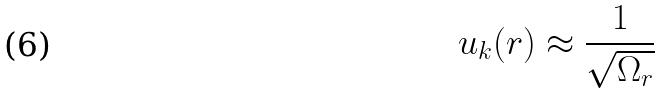<formula> <loc_0><loc_0><loc_500><loc_500>u _ { k } ( r ) \approx \frac { 1 } { \sqrt { \Omega _ { r } } }</formula> 